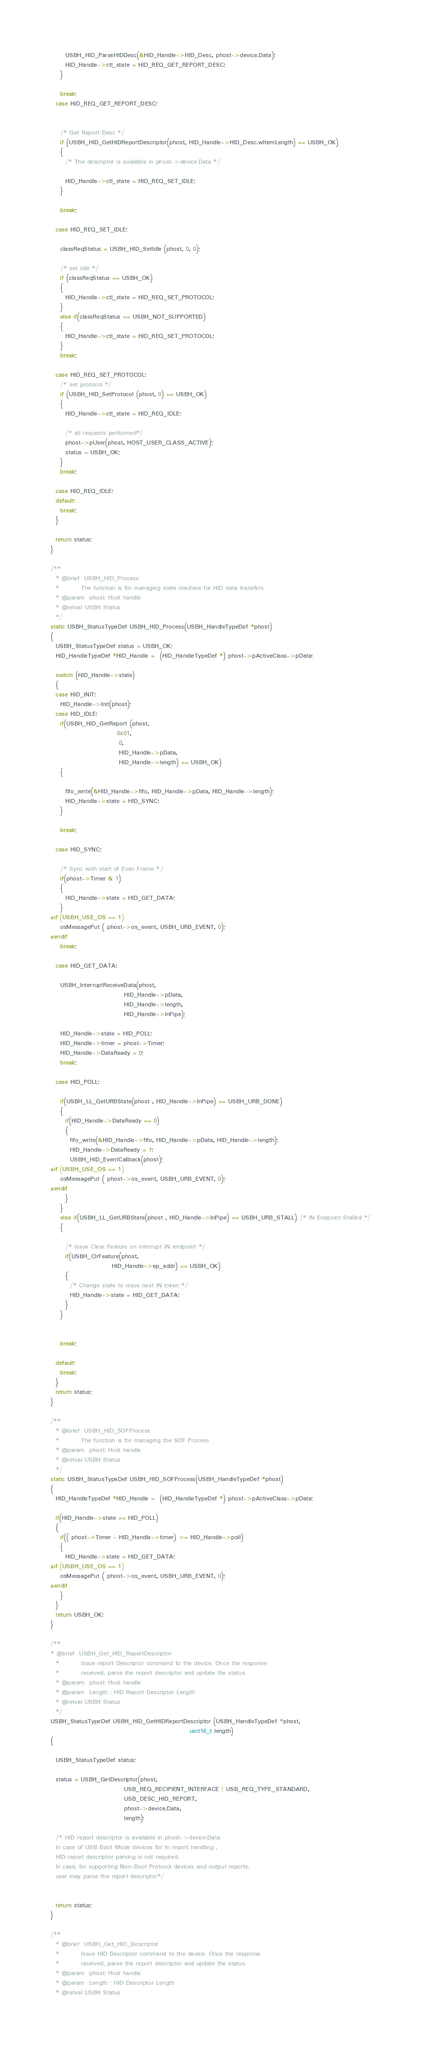Convert code to text. <code><loc_0><loc_0><loc_500><loc_500><_C_>      USBH_HID_ParseHIDDesc(&HID_Handle->HID_Desc, phost->device.Data);
      HID_Handle->ctl_state = HID_REQ_GET_REPORT_DESC;
    }
    
    break;     
  case HID_REQ_GET_REPORT_DESC:
    
    
    /* Get Report Desc */ 
    if (USBH_HID_GetHIDReportDescriptor(phost, HID_Handle->HID_Desc.wItemLength) == USBH_OK)
    {
      /* The descriptor is available in phost->device.Data */

      HID_Handle->ctl_state = HID_REQ_SET_IDLE;
    }
    
    break;
    
  case HID_REQ_SET_IDLE:
    
    classReqStatus = USBH_HID_SetIdle (phost, 0, 0);
    
    /* set Idle */
    if (classReqStatus == USBH_OK)
    {
      HID_Handle->ctl_state = HID_REQ_SET_PROTOCOL;  
    }
    else if(classReqStatus == USBH_NOT_SUPPORTED) 
    {
      HID_Handle->ctl_state = HID_REQ_SET_PROTOCOL;        
    } 
    break; 
    
  case HID_REQ_SET_PROTOCOL:
    /* set protocol */
    if (USBH_HID_SetProtocol (phost, 0) == USBH_OK)
    {
      HID_Handle->ctl_state = HID_REQ_IDLE;
      
      /* all requests performed*/
      phost->pUser(phost, HOST_USER_CLASS_ACTIVE); 
      status = USBH_OK; 
    } 
    break;
    
  case HID_REQ_IDLE:
  default:
    break;
  }
  
  return status; 
}

/**
  * @brief  USBH_HID_Process 
  *         The function is for managing state machine for HID data transfers 
  * @param  phost: Host handle
  * @retval USBH Status
  */
static USBH_StatusTypeDef USBH_HID_Process(USBH_HandleTypeDef *phost)
{
  USBH_StatusTypeDef status = USBH_OK;
  HID_HandleTypeDef *HID_Handle =  (HID_HandleTypeDef *) phost->pActiveClass->pData;
  
  switch (HID_Handle->state)
  {
  case HID_INIT:
    HID_Handle->Init(phost); 
  case HID_IDLE:
    if(USBH_HID_GetReport (phost,
                           0x01,
                            0,
                            HID_Handle->pData,
                            HID_Handle->length) == USBH_OK)
    {
      
      fifo_write(&HID_Handle->fifo, HID_Handle->pData, HID_Handle->length);  
      HID_Handle->state = HID_SYNC;
    }
    
    break;
    
  case HID_SYNC:

    /* Sync with start of Even Frame */
    if(phost->Timer & 1)
    {
      HID_Handle->state = HID_GET_DATA; 
    }
#if (USBH_USE_OS == 1)
    osMessagePut ( phost->os_event, USBH_URB_EVENT, 0);
#endif   
    break;
    
  case HID_GET_DATA:

    USBH_InterruptReceiveData(phost, 
                              HID_Handle->pData,
                              HID_Handle->length,
                              HID_Handle->InPipe);
    
    HID_Handle->state = HID_POLL;
    HID_Handle->timer = phost->Timer;
    HID_Handle->DataReady = 0;
    break;
    
  case HID_POLL:
    
    if(USBH_LL_GetURBState(phost , HID_Handle->InPipe) == USBH_URB_DONE)
    {
      if(HID_Handle->DataReady == 0)
      {
        fifo_write(&HID_Handle->fifo, HID_Handle->pData, HID_Handle->length);
        HID_Handle->DataReady = 1;
        USBH_HID_EventCallback(phost);
#if (USBH_USE_OS == 1)
    osMessagePut ( phost->os_event, USBH_URB_EVENT, 0);
#endif          
      }
    }
    else if(USBH_LL_GetURBState(phost , HID_Handle->InPipe) == USBH_URB_STALL) /* IN Endpoint Stalled */
    {
      
      /* Issue Clear Feature on interrupt IN endpoint */ 
      if(USBH_ClrFeature(phost,
                         HID_Handle->ep_addr) == USBH_OK)
      {
        /* Change state to issue next IN token */
        HID_Handle->state = HID_GET_DATA;
      }
    } 
    

    break;
    
  default:
    break;
  }
  return status;
}

/**
  * @brief  USBH_HID_SOFProcess 
  *         The function is for managing the SOF Process 
  * @param  phost: Host handle
  * @retval USBH Status
  */
static USBH_StatusTypeDef USBH_HID_SOFProcess(USBH_HandleTypeDef *phost)
{
  HID_HandleTypeDef *HID_Handle =  (HID_HandleTypeDef *) phost->pActiveClass->pData;
  
  if(HID_Handle->state == HID_POLL)
  {
    if(( phost->Timer - HID_Handle->timer) >= HID_Handle->poll)
    {
      HID_Handle->state = HID_GET_DATA;
#if (USBH_USE_OS == 1)
    osMessagePut ( phost->os_event, USBH_URB_EVENT, 0);
#endif       
    }
  }
  return USBH_OK;
}

/**
* @brief  USBH_Get_HID_ReportDescriptor
  *         Issue report Descriptor command to the device. Once the response 
  *         received, parse the report descriptor and update the status.
  * @param  phost: Host handle
  * @param  Length : HID Report Descriptor Length
  * @retval USBH Status
  */
USBH_StatusTypeDef USBH_HID_GetHIDReportDescriptor (USBH_HandleTypeDef *phost,
                                                         uint16_t length)
{
  
  USBH_StatusTypeDef status;
  
  status = USBH_GetDescriptor(phost,
                              USB_REQ_RECIPIENT_INTERFACE | USB_REQ_TYPE_STANDARD,                                  
                              USB_DESC_HID_REPORT, 
                              phost->device.Data,
                              length);
  
  /* HID report descriptor is available in phost->device.Data.
  In case of USB Boot Mode devices for In report handling ,
  HID report descriptor parsing is not required.
  In case, for supporting Non-Boot Protocol devices and output reports,
  user may parse the report descriptor*/
  
  
  return status;
}

/**
  * @brief  USBH_Get_HID_Descriptor
  *         Issue HID Descriptor command to the device. Once the response 
  *         received, parse the report descriptor and update the status.
  * @param  phost: Host handle
  * @param  Length : HID Descriptor Length
  * @retval USBH Status</code> 